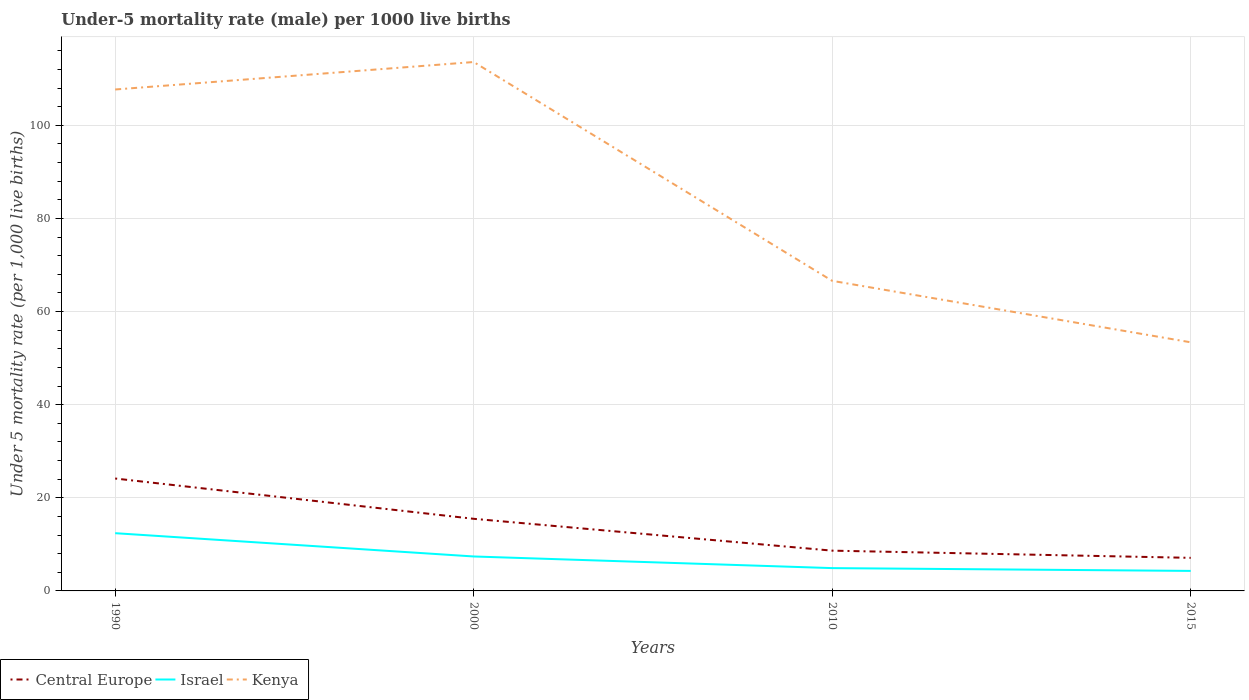Does the line corresponding to Israel intersect with the line corresponding to Central Europe?
Your answer should be very brief. No. Is the number of lines equal to the number of legend labels?
Offer a very short reply. Yes. In which year was the under-five mortality rate in Israel maximum?
Give a very brief answer. 2015. What is the total under-five mortality rate in Central Europe in the graph?
Ensure brevity in your answer.  6.84. What is the difference between the highest and the second highest under-five mortality rate in Israel?
Give a very brief answer. 8.1. What is the difference between the highest and the lowest under-five mortality rate in Israel?
Ensure brevity in your answer.  2. How many years are there in the graph?
Your answer should be very brief. 4. Are the values on the major ticks of Y-axis written in scientific E-notation?
Provide a short and direct response. No. Where does the legend appear in the graph?
Your response must be concise. Bottom left. How are the legend labels stacked?
Give a very brief answer. Horizontal. What is the title of the graph?
Your answer should be very brief. Under-5 mortality rate (male) per 1000 live births. Does "Sao Tome and Principe" appear as one of the legend labels in the graph?
Offer a very short reply. No. What is the label or title of the Y-axis?
Offer a very short reply. Under 5 mortality rate (per 1,0 live births). What is the Under 5 mortality rate (per 1,000 live births) in Central Europe in 1990?
Offer a terse response. 24.14. What is the Under 5 mortality rate (per 1,000 live births) of Israel in 1990?
Your answer should be very brief. 12.4. What is the Under 5 mortality rate (per 1,000 live births) in Kenya in 1990?
Keep it short and to the point. 107.7. What is the Under 5 mortality rate (per 1,000 live births) in Central Europe in 2000?
Keep it short and to the point. 15.49. What is the Under 5 mortality rate (per 1,000 live births) in Israel in 2000?
Your response must be concise. 7.4. What is the Under 5 mortality rate (per 1,000 live births) of Kenya in 2000?
Your answer should be compact. 113.6. What is the Under 5 mortality rate (per 1,000 live births) of Central Europe in 2010?
Keep it short and to the point. 8.65. What is the Under 5 mortality rate (per 1,000 live births) of Kenya in 2010?
Your answer should be very brief. 66.6. What is the Under 5 mortality rate (per 1,000 live births) in Central Europe in 2015?
Offer a very short reply. 7.1. What is the Under 5 mortality rate (per 1,000 live births) in Kenya in 2015?
Ensure brevity in your answer.  53.4. Across all years, what is the maximum Under 5 mortality rate (per 1,000 live births) of Central Europe?
Keep it short and to the point. 24.14. Across all years, what is the maximum Under 5 mortality rate (per 1,000 live births) of Kenya?
Your answer should be compact. 113.6. Across all years, what is the minimum Under 5 mortality rate (per 1,000 live births) of Central Europe?
Keep it short and to the point. 7.1. Across all years, what is the minimum Under 5 mortality rate (per 1,000 live births) in Israel?
Your answer should be compact. 4.3. Across all years, what is the minimum Under 5 mortality rate (per 1,000 live births) of Kenya?
Keep it short and to the point. 53.4. What is the total Under 5 mortality rate (per 1,000 live births) of Central Europe in the graph?
Keep it short and to the point. 55.39. What is the total Under 5 mortality rate (per 1,000 live births) in Israel in the graph?
Provide a succinct answer. 29. What is the total Under 5 mortality rate (per 1,000 live births) of Kenya in the graph?
Make the answer very short. 341.3. What is the difference between the Under 5 mortality rate (per 1,000 live births) in Central Europe in 1990 and that in 2000?
Make the answer very short. 8.65. What is the difference between the Under 5 mortality rate (per 1,000 live births) of Israel in 1990 and that in 2000?
Provide a succinct answer. 5. What is the difference between the Under 5 mortality rate (per 1,000 live births) in Central Europe in 1990 and that in 2010?
Your answer should be very brief. 15.5. What is the difference between the Under 5 mortality rate (per 1,000 live births) of Israel in 1990 and that in 2010?
Offer a terse response. 7.5. What is the difference between the Under 5 mortality rate (per 1,000 live births) of Kenya in 1990 and that in 2010?
Offer a terse response. 41.1. What is the difference between the Under 5 mortality rate (per 1,000 live births) in Central Europe in 1990 and that in 2015?
Make the answer very short. 17.04. What is the difference between the Under 5 mortality rate (per 1,000 live births) of Israel in 1990 and that in 2015?
Offer a very short reply. 8.1. What is the difference between the Under 5 mortality rate (per 1,000 live births) in Kenya in 1990 and that in 2015?
Your answer should be compact. 54.3. What is the difference between the Under 5 mortality rate (per 1,000 live births) in Central Europe in 2000 and that in 2010?
Provide a short and direct response. 6.84. What is the difference between the Under 5 mortality rate (per 1,000 live births) in Israel in 2000 and that in 2010?
Ensure brevity in your answer.  2.5. What is the difference between the Under 5 mortality rate (per 1,000 live births) in Kenya in 2000 and that in 2010?
Your response must be concise. 47. What is the difference between the Under 5 mortality rate (per 1,000 live births) in Central Europe in 2000 and that in 2015?
Give a very brief answer. 8.38. What is the difference between the Under 5 mortality rate (per 1,000 live births) in Israel in 2000 and that in 2015?
Your response must be concise. 3.1. What is the difference between the Under 5 mortality rate (per 1,000 live births) in Kenya in 2000 and that in 2015?
Provide a short and direct response. 60.2. What is the difference between the Under 5 mortality rate (per 1,000 live births) of Central Europe in 2010 and that in 2015?
Offer a terse response. 1.54. What is the difference between the Under 5 mortality rate (per 1,000 live births) of Kenya in 2010 and that in 2015?
Your response must be concise. 13.2. What is the difference between the Under 5 mortality rate (per 1,000 live births) in Central Europe in 1990 and the Under 5 mortality rate (per 1,000 live births) in Israel in 2000?
Provide a succinct answer. 16.74. What is the difference between the Under 5 mortality rate (per 1,000 live births) of Central Europe in 1990 and the Under 5 mortality rate (per 1,000 live births) of Kenya in 2000?
Provide a succinct answer. -89.46. What is the difference between the Under 5 mortality rate (per 1,000 live births) of Israel in 1990 and the Under 5 mortality rate (per 1,000 live births) of Kenya in 2000?
Make the answer very short. -101.2. What is the difference between the Under 5 mortality rate (per 1,000 live births) of Central Europe in 1990 and the Under 5 mortality rate (per 1,000 live births) of Israel in 2010?
Your answer should be compact. 19.24. What is the difference between the Under 5 mortality rate (per 1,000 live births) in Central Europe in 1990 and the Under 5 mortality rate (per 1,000 live births) in Kenya in 2010?
Your response must be concise. -42.46. What is the difference between the Under 5 mortality rate (per 1,000 live births) of Israel in 1990 and the Under 5 mortality rate (per 1,000 live births) of Kenya in 2010?
Provide a short and direct response. -54.2. What is the difference between the Under 5 mortality rate (per 1,000 live births) in Central Europe in 1990 and the Under 5 mortality rate (per 1,000 live births) in Israel in 2015?
Provide a succinct answer. 19.84. What is the difference between the Under 5 mortality rate (per 1,000 live births) in Central Europe in 1990 and the Under 5 mortality rate (per 1,000 live births) in Kenya in 2015?
Provide a succinct answer. -29.26. What is the difference between the Under 5 mortality rate (per 1,000 live births) of Israel in 1990 and the Under 5 mortality rate (per 1,000 live births) of Kenya in 2015?
Offer a terse response. -41. What is the difference between the Under 5 mortality rate (per 1,000 live births) of Central Europe in 2000 and the Under 5 mortality rate (per 1,000 live births) of Israel in 2010?
Your answer should be very brief. 10.59. What is the difference between the Under 5 mortality rate (per 1,000 live births) of Central Europe in 2000 and the Under 5 mortality rate (per 1,000 live births) of Kenya in 2010?
Ensure brevity in your answer.  -51.11. What is the difference between the Under 5 mortality rate (per 1,000 live births) of Israel in 2000 and the Under 5 mortality rate (per 1,000 live births) of Kenya in 2010?
Give a very brief answer. -59.2. What is the difference between the Under 5 mortality rate (per 1,000 live births) of Central Europe in 2000 and the Under 5 mortality rate (per 1,000 live births) of Israel in 2015?
Offer a very short reply. 11.19. What is the difference between the Under 5 mortality rate (per 1,000 live births) in Central Europe in 2000 and the Under 5 mortality rate (per 1,000 live births) in Kenya in 2015?
Give a very brief answer. -37.91. What is the difference between the Under 5 mortality rate (per 1,000 live births) of Israel in 2000 and the Under 5 mortality rate (per 1,000 live births) of Kenya in 2015?
Give a very brief answer. -46. What is the difference between the Under 5 mortality rate (per 1,000 live births) in Central Europe in 2010 and the Under 5 mortality rate (per 1,000 live births) in Israel in 2015?
Offer a very short reply. 4.35. What is the difference between the Under 5 mortality rate (per 1,000 live births) of Central Europe in 2010 and the Under 5 mortality rate (per 1,000 live births) of Kenya in 2015?
Make the answer very short. -44.75. What is the difference between the Under 5 mortality rate (per 1,000 live births) in Israel in 2010 and the Under 5 mortality rate (per 1,000 live births) in Kenya in 2015?
Provide a short and direct response. -48.5. What is the average Under 5 mortality rate (per 1,000 live births) in Central Europe per year?
Your answer should be very brief. 13.85. What is the average Under 5 mortality rate (per 1,000 live births) in Israel per year?
Keep it short and to the point. 7.25. What is the average Under 5 mortality rate (per 1,000 live births) of Kenya per year?
Provide a succinct answer. 85.33. In the year 1990, what is the difference between the Under 5 mortality rate (per 1,000 live births) in Central Europe and Under 5 mortality rate (per 1,000 live births) in Israel?
Keep it short and to the point. 11.74. In the year 1990, what is the difference between the Under 5 mortality rate (per 1,000 live births) of Central Europe and Under 5 mortality rate (per 1,000 live births) of Kenya?
Keep it short and to the point. -83.56. In the year 1990, what is the difference between the Under 5 mortality rate (per 1,000 live births) in Israel and Under 5 mortality rate (per 1,000 live births) in Kenya?
Ensure brevity in your answer.  -95.3. In the year 2000, what is the difference between the Under 5 mortality rate (per 1,000 live births) in Central Europe and Under 5 mortality rate (per 1,000 live births) in Israel?
Offer a terse response. 8.09. In the year 2000, what is the difference between the Under 5 mortality rate (per 1,000 live births) of Central Europe and Under 5 mortality rate (per 1,000 live births) of Kenya?
Provide a short and direct response. -98.11. In the year 2000, what is the difference between the Under 5 mortality rate (per 1,000 live births) of Israel and Under 5 mortality rate (per 1,000 live births) of Kenya?
Provide a short and direct response. -106.2. In the year 2010, what is the difference between the Under 5 mortality rate (per 1,000 live births) in Central Europe and Under 5 mortality rate (per 1,000 live births) in Israel?
Provide a succinct answer. 3.75. In the year 2010, what is the difference between the Under 5 mortality rate (per 1,000 live births) of Central Europe and Under 5 mortality rate (per 1,000 live births) of Kenya?
Offer a terse response. -57.95. In the year 2010, what is the difference between the Under 5 mortality rate (per 1,000 live births) of Israel and Under 5 mortality rate (per 1,000 live births) of Kenya?
Give a very brief answer. -61.7. In the year 2015, what is the difference between the Under 5 mortality rate (per 1,000 live births) of Central Europe and Under 5 mortality rate (per 1,000 live births) of Israel?
Keep it short and to the point. 2.8. In the year 2015, what is the difference between the Under 5 mortality rate (per 1,000 live births) in Central Europe and Under 5 mortality rate (per 1,000 live births) in Kenya?
Make the answer very short. -46.3. In the year 2015, what is the difference between the Under 5 mortality rate (per 1,000 live births) of Israel and Under 5 mortality rate (per 1,000 live births) of Kenya?
Your response must be concise. -49.1. What is the ratio of the Under 5 mortality rate (per 1,000 live births) of Central Europe in 1990 to that in 2000?
Offer a terse response. 1.56. What is the ratio of the Under 5 mortality rate (per 1,000 live births) in Israel in 1990 to that in 2000?
Keep it short and to the point. 1.68. What is the ratio of the Under 5 mortality rate (per 1,000 live births) in Kenya in 1990 to that in 2000?
Keep it short and to the point. 0.95. What is the ratio of the Under 5 mortality rate (per 1,000 live births) of Central Europe in 1990 to that in 2010?
Make the answer very short. 2.79. What is the ratio of the Under 5 mortality rate (per 1,000 live births) in Israel in 1990 to that in 2010?
Ensure brevity in your answer.  2.53. What is the ratio of the Under 5 mortality rate (per 1,000 live births) of Kenya in 1990 to that in 2010?
Make the answer very short. 1.62. What is the ratio of the Under 5 mortality rate (per 1,000 live births) in Central Europe in 1990 to that in 2015?
Ensure brevity in your answer.  3.4. What is the ratio of the Under 5 mortality rate (per 1,000 live births) of Israel in 1990 to that in 2015?
Your answer should be very brief. 2.88. What is the ratio of the Under 5 mortality rate (per 1,000 live births) of Kenya in 1990 to that in 2015?
Your answer should be compact. 2.02. What is the ratio of the Under 5 mortality rate (per 1,000 live births) of Central Europe in 2000 to that in 2010?
Offer a very short reply. 1.79. What is the ratio of the Under 5 mortality rate (per 1,000 live births) of Israel in 2000 to that in 2010?
Your answer should be very brief. 1.51. What is the ratio of the Under 5 mortality rate (per 1,000 live births) of Kenya in 2000 to that in 2010?
Provide a short and direct response. 1.71. What is the ratio of the Under 5 mortality rate (per 1,000 live births) of Central Europe in 2000 to that in 2015?
Your response must be concise. 2.18. What is the ratio of the Under 5 mortality rate (per 1,000 live births) of Israel in 2000 to that in 2015?
Provide a succinct answer. 1.72. What is the ratio of the Under 5 mortality rate (per 1,000 live births) of Kenya in 2000 to that in 2015?
Make the answer very short. 2.13. What is the ratio of the Under 5 mortality rate (per 1,000 live births) of Central Europe in 2010 to that in 2015?
Offer a terse response. 1.22. What is the ratio of the Under 5 mortality rate (per 1,000 live births) in Israel in 2010 to that in 2015?
Your response must be concise. 1.14. What is the ratio of the Under 5 mortality rate (per 1,000 live births) in Kenya in 2010 to that in 2015?
Offer a terse response. 1.25. What is the difference between the highest and the second highest Under 5 mortality rate (per 1,000 live births) of Central Europe?
Ensure brevity in your answer.  8.65. What is the difference between the highest and the second highest Under 5 mortality rate (per 1,000 live births) of Israel?
Ensure brevity in your answer.  5. What is the difference between the highest and the lowest Under 5 mortality rate (per 1,000 live births) in Central Europe?
Your answer should be compact. 17.04. What is the difference between the highest and the lowest Under 5 mortality rate (per 1,000 live births) of Israel?
Your response must be concise. 8.1. What is the difference between the highest and the lowest Under 5 mortality rate (per 1,000 live births) of Kenya?
Your answer should be very brief. 60.2. 